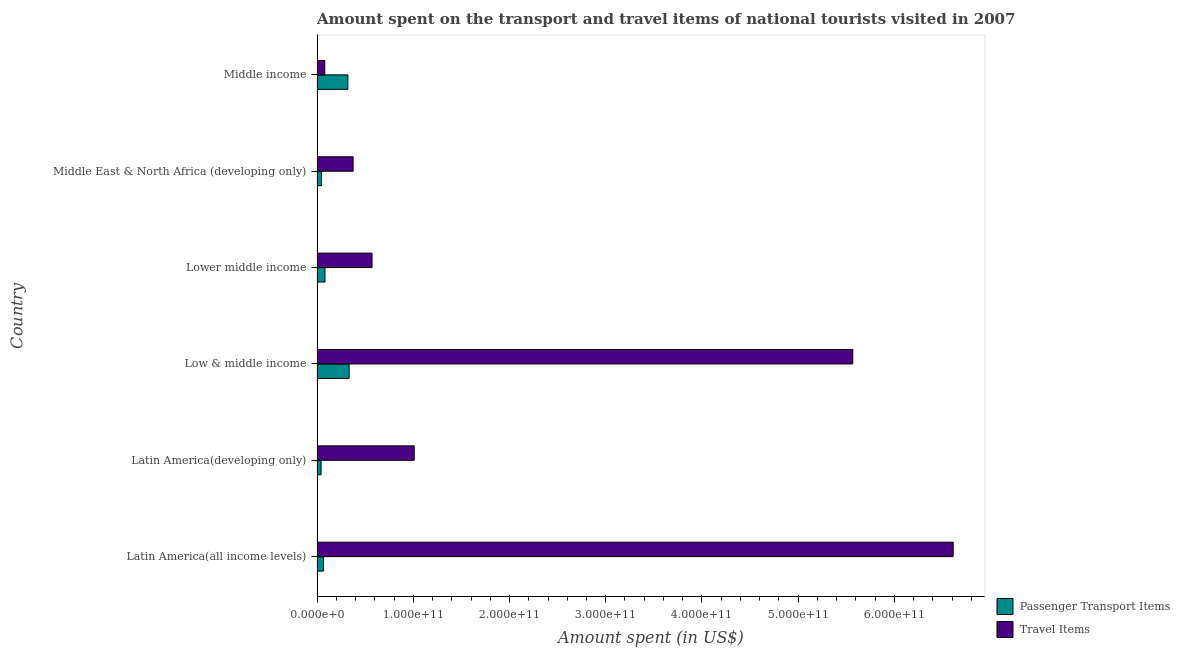How many different coloured bars are there?
Offer a terse response. 2. Are the number of bars on each tick of the Y-axis equal?
Offer a very short reply. Yes. How many bars are there on the 6th tick from the top?
Make the answer very short. 2. What is the label of the 5th group of bars from the top?
Your answer should be compact. Latin America(developing only). In how many cases, is the number of bars for a given country not equal to the number of legend labels?
Keep it short and to the point. 0. What is the amount spent on passenger transport items in Low & middle income?
Make the answer very short. 3.34e+1. Across all countries, what is the maximum amount spent in travel items?
Make the answer very short. 6.61e+11. Across all countries, what is the minimum amount spent in travel items?
Keep it short and to the point. 8.03e+09. In which country was the amount spent in travel items maximum?
Give a very brief answer. Latin America(all income levels). In which country was the amount spent in travel items minimum?
Give a very brief answer. Middle income. What is the total amount spent in travel items in the graph?
Give a very brief answer. 1.42e+12. What is the difference between the amount spent in travel items in Latin America(developing only) and that in Lower middle income?
Offer a terse response. 4.38e+1. What is the difference between the amount spent in travel items in Latin America(developing only) and the amount spent on passenger transport items in Lower middle income?
Make the answer very short. 9.27e+1. What is the average amount spent in travel items per country?
Provide a short and direct response. 2.37e+11. What is the difference between the amount spent in travel items and amount spent on passenger transport items in Latin America(developing only)?
Keep it short and to the point. 9.68e+1. In how many countries, is the amount spent on passenger transport items greater than 400000000000 US$?
Your response must be concise. 0. What is the ratio of the amount spent on passenger transport items in Latin America(developing only) to that in Middle income?
Ensure brevity in your answer.  0.13. Is the difference between the amount spent in travel items in Latin America(all income levels) and Low & middle income greater than the difference between the amount spent on passenger transport items in Latin America(all income levels) and Low & middle income?
Your response must be concise. Yes. What is the difference between the highest and the second highest amount spent in travel items?
Provide a succinct answer. 1.04e+11. What is the difference between the highest and the lowest amount spent on passenger transport items?
Provide a short and direct response. 2.92e+1. In how many countries, is the amount spent on passenger transport items greater than the average amount spent on passenger transport items taken over all countries?
Provide a succinct answer. 2. Is the sum of the amount spent in travel items in Latin America(all income levels) and Middle income greater than the maximum amount spent on passenger transport items across all countries?
Ensure brevity in your answer.  Yes. What does the 1st bar from the top in Lower middle income represents?
Your answer should be compact. Travel Items. What does the 1st bar from the bottom in Lower middle income represents?
Give a very brief answer. Passenger Transport Items. What is the difference between two consecutive major ticks on the X-axis?
Your answer should be compact. 1.00e+11. Does the graph contain any zero values?
Make the answer very short. No. Does the graph contain grids?
Your answer should be very brief. No. How are the legend labels stacked?
Give a very brief answer. Vertical. What is the title of the graph?
Your answer should be compact. Amount spent on the transport and travel items of national tourists visited in 2007. What is the label or title of the X-axis?
Make the answer very short. Amount spent (in US$). What is the Amount spent (in US$) in Passenger Transport Items in Latin America(all income levels)?
Provide a succinct answer. 6.67e+09. What is the Amount spent (in US$) in Travel Items in Latin America(all income levels)?
Your response must be concise. 6.61e+11. What is the Amount spent (in US$) of Passenger Transport Items in Latin America(developing only)?
Provide a short and direct response. 4.17e+09. What is the Amount spent (in US$) in Travel Items in Latin America(developing only)?
Provide a short and direct response. 1.01e+11. What is the Amount spent (in US$) in Passenger Transport Items in Low & middle income?
Make the answer very short. 3.34e+1. What is the Amount spent (in US$) in Travel Items in Low & middle income?
Offer a very short reply. 5.57e+11. What is the Amount spent (in US$) in Passenger Transport Items in Lower middle income?
Your answer should be compact. 8.22e+09. What is the Amount spent (in US$) of Travel Items in Lower middle income?
Provide a succinct answer. 5.71e+1. What is the Amount spent (in US$) of Passenger Transport Items in Middle East & North Africa (developing only)?
Make the answer very short. 4.64e+09. What is the Amount spent (in US$) in Travel Items in Middle East & North Africa (developing only)?
Your answer should be compact. 3.75e+1. What is the Amount spent (in US$) in Passenger Transport Items in Middle income?
Ensure brevity in your answer.  3.20e+1. What is the Amount spent (in US$) of Travel Items in Middle income?
Your answer should be compact. 8.03e+09. Across all countries, what is the maximum Amount spent (in US$) in Passenger Transport Items?
Offer a very short reply. 3.34e+1. Across all countries, what is the maximum Amount spent (in US$) in Travel Items?
Your answer should be very brief. 6.61e+11. Across all countries, what is the minimum Amount spent (in US$) of Passenger Transport Items?
Provide a short and direct response. 4.17e+09. Across all countries, what is the minimum Amount spent (in US$) in Travel Items?
Ensure brevity in your answer.  8.03e+09. What is the total Amount spent (in US$) in Passenger Transport Items in the graph?
Provide a succinct answer. 8.91e+1. What is the total Amount spent (in US$) of Travel Items in the graph?
Give a very brief answer. 1.42e+12. What is the difference between the Amount spent (in US$) of Passenger Transport Items in Latin America(all income levels) and that in Latin America(developing only)?
Your response must be concise. 2.50e+09. What is the difference between the Amount spent (in US$) of Travel Items in Latin America(all income levels) and that in Latin America(developing only)?
Keep it short and to the point. 5.60e+11. What is the difference between the Amount spent (in US$) of Passenger Transport Items in Latin America(all income levels) and that in Low & middle income?
Your response must be concise. -2.67e+1. What is the difference between the Amount spent (in US$) of Travel Items in Latin America(all income levels) and that in Low & middle income?
Your answer should be compact. 1.04e+11. What is the difference between the Amount spent (in US$) in Passenger Transport Items in Latin America(all income levels) and that in Lower middle income?
Your answer should be very brief. -1.55e+09. What is the difference between the Amount spent (in US$) in Travel Items in Latin America(all income levels) and that in Lower middle income?
Provide a succinct answer. 6.04e+11. What is the difference between the Amount spent (in US$) in Passenger Transport Items in Latin America(all income levels) and that in Middle East & North Africa (developing only)?
Your response must be concise. 2.03e+09. What is the difference between the Amount spent (in US$) of Travel Items in Latin America(all income levels) and that in Middle East & North Africa (developing only)?
Your answer should be compact. 6.24e+11. What is the difference between the Amount spent (in US$) in Passenger Transport Items in Latin America(all income levels) and that in Middle income?
Make the answer very short. -2.54e+1. What is the difference between the Amount spent (in US$) of Travel Items in Latin America(all income levels) and that in Middle income?
Ensure brevity in your answer.  6.53e+11. What is the difference between the Amount spent (in US$) in Passenger Transport Items in Latin America(developing only) and that in Low & middle income?
Keep it short and to the point. -2.92e+1. What is the difference between the Amount spent (in US$) in Travel Items in Latin America(developing only) and that in Low & middle income?
Provide a short and direct response. -4.56e+11. What is the difference between the Amount spent (in US$) in Passenger Transport Items in Latin America(developing only) and that in Lower middle income?
Your answer should be very brief. -4.05e+09. What is the difference between the Amount spent (in US$) in Travel Items in Latin America(developing only) and that in Lower middle income?
Offer a terse response. 4.38e+1. What is the difference between the Amount spent (in US$) in Passenger Transport Items in Latin America(developing only) and that in Middle East & North Africa (developing only)?
Give a very brief answer. -4.66e+08. What is the difference between the Amount spent (in US$) of Travel Items in Latin America(developing only) and that in Middle East & North Africa (developing only)?
Ensure brevity in your answer.  6.35e+1. What is the difference between the Amount spent (in US$) of Passenger Transport Items in Latin America(developing only) and that in Middle income?
Your answer should be very brief. -2.79e+1. What is the difference between the Amount spent (in US$) in Travel Items in Latin America(developing only) and that in Middle income?
Your answer should be compact. 9.29e+1. What is the difference between the Amount spent (in US$) in Passenger Transport Items in Low & middle income and that in Lower middle income?
Your response must be concise. 2.51e+1. What is the difference between the Amount spent (in US$) of Travel Items in Low & middle income and that in Lower middle income?
Make the answer very short. 5.00e+11. What is the difference between the Amount spent (in US$) of Passenger Transport Items in Low & middle income and that in Middle East & North Africa (developing only)?
Ensure brevity in your answer.  2.87e+1. What is the difference between the Amount spent (in US$) in Travel Items in Low & middle income and that in Middle East & North Africa (developing only)?
Your answer should be compact. 5.19e+11. What is the difference between the Amount spent (in US$) in Passenger Transport Items in Low & middle income and that in Middle income?
Offer a terse response. 1.33e+09. What is the difference between the Amount spent (in US$) of Travel Items in Low & middle income and that in Middle income?
Provide a short and direct response. 5.49e+11. What is the difference between the Amount spent (in US$) of Passenger Transport Items in Lower middle income and that in Middle East & North Africa (developing only)?
Your response must be concise. 3.58e+09. What is the difference between the Amount spent (in US$) in Travel Items in Lower middle income and that in Middle East & North Africa (developing only)?
Make the answer very short. 1.97e+1. What is the difference between the Amount spent (in US$) in Passenger Transport Items in Lower middle income and that in Middle income?
Provide a short and direct response. -2.38e+1. What is the difference between the Amount spent (in US$) of Travel Items in Lower middle income and that in Middle income?
Your response must be concise. 4.91e+1. What is the difference between the Amount spent (in US$) in Passenger Transport Items in Middle East & North Africa (developing only) and that in Middle income?
Your answer should be compact. -2.74e+1. What is the difference between the Amount spent (in US$) in Travel Items in Middle East & North Africa (developing only) and that in Middle income?
Give a very brief answer. 2.94e+1. What is the difference between the Amount spent (in US$) in Passenger Transport Items in Latin America(all income levels) and the Amount spent (in US$) in Travel Items in Latin America(developing only)?
Your response must be concise. -9.43e+1. What is the difference between the Amount spent (in US$) in Passenger Transport Items in Latin America(all income levels) and the Amount spent (in US$) in Travel Items in Low & middle income?
Provide a succinct answer. -5.50e+11. What is the difference between the Amount spent (in US$) in Passenger Transport Items in Latin America(all income levels) and the Amount spent (in US$) in Travel Items in Lower middle income?
Keep it short and to the point. -5.05e+1. What is the difference between the Amount spent (in US$) of Passenger Transport Items in Latin America(all income levels) and the Amount spent (in US$) of Travel Items in Middle East & North Africa (developing only)?
Provide a succinct answer. -3.08e+1. What is the difference between the Amount spent (in US$) of Passenger Transport Items in Latin America(all income levels) and the Amount spent (in US$) of Travel Items in Middle income?
Keep it short and to the point. -1.36e+09. What is the difference between the Amount spent (in US$) in Passenger Transport Items in Latin America(developing only) and the Amount spent (in US$) in Travel Items in Low & middle income?
Give a very brief answer. -5.53e+11. What is the difference between the Amount spent (in US$) in Passenger Transport Items in Latin America(developing only) and the Amount spent (in US$) in Travel Items in Lower middle income?
Offer a terse response. -5.30e+1. What is the difference between the Amount spent (in US$) in Passenger Transport Items in Latin America(developing only) and the Amount spent (in US$) in Travel Items in Middle East & North Africa (developing only)?
Your response must be concise. -3.33e+1. What is the difference between the Amount spent (in US$) of Passenger Transport Items in Latin America(developing only) and the Amount spent (in US$) of Travel Items in Middle income?
Offer a very short reply. -3.86e+09. What is the difference between the Amount spent (in US$) of Passenger Transport Items in Low & middle income and the Amount spent (in US$) of Travel Items in Lower middle income?
Give a very brief answer. -2.38e+1. What is the difference between the Amount spent (in US$) in Passenger Transport Items in Low & middle income and the Amount spent (in US$) in Travel Items in Middle East & North Africa (developing only)?
Provide a short and direct response. -4.13e+09. What is the difference between the Amount spent (in US$) of Passenger Transport Items in Low & middle income and the Amount spent (in US$) of Travel Items in Middle income?
Provide a short and direct response. 2.53e+1. What is the difference between the Amount spent (in US$) of Passenger Transport Items in Lower middle income and the Amount spent (in US$) of Travel Items in Middle East & North Africa (developing only)?
Provide a succinct answer. -2.93e+1. What is the difference between the Amount spent (in US$) of Passenger Transport Items in Lower middle income and the Amount spent (in US$) of Travel Items in Middle income?
Offer a very short reply. 1.87e+08. What is the difference between the Amount spent (in US$) of Passenger Transport Items in Middle East & North Africa (developing only) and the Amount spent (in US$) of Travel Items in Middle income?
Give a very brief answer. -3.39e+09. What is the average Amount spent (in US$) in Passenger Transport Items per country?
Keep it short and to the point. 1.48e+1. What is the average Amount spent (in US$) of Travel Items per country?
Make the answer very short. 2.37e+11. What is the difference between the Amount spent (in US$) in Passenger Transport Items and Amount spent (in US$) in Travel Items in Latin America(all income levels)?
Offer a very short reply. -6.54e+11. What is the difference between the Amount spent (in US$) in Passenger Transport Items and Amount spent (in US$) in Travel Items in Latin America(developing only)?
Offer a terse response. -9.68e+1. What is the difference between the Amount spent (in US$) of Passenger Transport Items and Amount spent (in US$) of Travel Items in Low & middle income?
Ensure brevity in your answer.  -5.23e+11. What is the difference between the Amount spent (in US$) of Passenger Transport Items and Amount spent (in US$) of Travel Items in Lower middle income?
Your answer should be very brief. -4.89e+1. What is the difference between the Amount spent (in US$) in Passenger Transport Items and Amount spent (in US$) in Travel Items in Middle East & North Africa (developing only)?
Keep it short and to the point. -3.28e+1. What is the difference between the Amount spent (in US$) of Passenger Transport Items and Amount spent (in US$) of Travel Items in Middle income?
Give a very brief answer. 2.40e+1. What is the ratio of the Amount spent (in US$) in Passenger Transport Items in Latin America(all income levels) to that in Latin America(developing only)?
Your answer should be very brief. 1.6. What is the ratio of the Amount spent (in US$) in Travel Items in Latin America(all income levels) to that in Latin America(developing only)?
Your answer should be compact. 6.55. What is the ratio of the Amount spent (in US$) in Travel Items in Latin America(all income levels) to that in Low & middle income?
Offer a very short reply. 1.19. What is the ratio of the Amount spent (in US$) in Passenger Transport Items in Latin America(all income levels) to that in Lower middle income?
Offer a terse response. 0.81. What is the ratio of the Amount spent (in US$) in Travel Items in Latin America(all income levels) to that in Lower middle income?
Keep it short and to the point. 11.57. What is the ratio of the Amount spent (in US$) of Passenger Transport Items in Latin America(all income levels) to that in Middle East & North Africa (developing only)?
Offer a very short reply. 1.44. What is the ratio of the Amount spent (in US$) in Travel Items in Latin America(all income levels) to that in Middle East & North Africa (developing only)?
Provide a short and direct response. 17.64. What is the ratio of the Amount spent (in US$) of Passenger Transport Items in Latin America(all income levels) to that in Middle income?
Provide a succinct answer. 0.21. What is the ratio of the Amount spent (in US$) in Travel Items in Latin America(all income levels) to that in Middle income?
Make the answer very short. 82.29. What is the ratio of the Amount spent (in US$) of Passenger Transport Items in Latin America(developing only) to that in Low & middle income?
Your answer should be compact. 0.13. What is the ratio of the Amount spent (in US$) in Travel Items in Latin America(developing only) to that in Low & middle income?
Your answer should be very brief. 0.18. What is the ratio of the Amount spent (in US$) in Passenger Transport Items in Latin America(developing only) to that in Lower middle income?
Ensure brevity in your answer.  0.51. What is the ratio of the Amount spent (in US$) in Travel Items in Latin America(developing only) to that in Lower middle income?
Your answer should be compact. 1.77. What is the ratio of the Amount spent (in US$) in Passenger Transport Items in Latin America(developing only) to that in Middle East & North Africa (developing only)?
Make the answer very short. 0.9. What is the ratio of the Amount spent (in US$) in Travel Items in Latin America(developing only) to that in Middle East & North Africa (developing only)?
Your answer should be very brief. 2.69. What is the ratio of the Amount spent (in US$) in Passenger Transport Items in Latin America(developing only) to that in Middle income?
Your answer should be compact. 0.13. What is the ratio of the Amount spent (in US$) of Travel Items in Latin America(developing only) to that in Middle income?
Provide a succinct answer. 12.57. What is the ratio of the Amount spent (in US$) of Passenger Transport Items in Low & middle income to that in Lower middle income?
Offer a terse response. 4.06. What is the ratio of the Amount spent (in US$) of Travel Items in Low & middle income to that in Lower middle income?
Your answer should be very brief. 9.74. What is the ratio of the Amount spent (in US$) of Passenger Transport Items in Low & middle income to that in Middle East & North Africa (developing only)?
Keep it short and to the point. 7.19. What is the ratio of the Amount spent (in US$) in Travel Items in Low & middle income to that in Middle East & North Africa (developing only)?
Give a very brief answer. 14.85. What is the ratio of the Amount spent (in US$) of Passenger Transport Items in Low & middle income to that in Middle income?
Provide a short and direct response. 1.04. What is the ratio of the Amount spent (in US$) of Travel Items in Low & middle income to that in Middle income?
Ensure brevity in your answer.  69.3. What is the ratio of the Amount spent (in US$) of Passenger Transport Items in Lower middle income to that in Middle East & North Africa (developing only)?
Provide a succinct answer. 1.77. What is the ratio of the Amount spent (in US$) of Travel Items in Lower middle income to that in Middle East & North Africa (developing only)?
Keep it short and to the point. 1.52. What is the ratio of the Amount spent (in US$) in Passenger Transport Items in Lower middle income to that in Middle income?
Your response must be concise. 0.26. What is the ratio of the Amount spent (in US$) in Travel Items in Lower middle income to that in Middle income?
Provide a succinct answer. 7.11. What is the ratio of the Amount spent (in US$) of Passenger Transport Items in Middle East & North Africa (developing only) to that in Middle income?
Provide a short and direct response. 0.14. What is the ratio of the Amount spent (in US$) in Travel Items in Middle East & North Africa (developing only) to that in Middle income?
Make the answer very short. 4.67. What is the difference between the highest and the second highest Amount spent (in US$) of Passenger Transport Items?
Offer a terse response. 1.33e+09. What is the difference between the highest and the second highest Amount spent (in US$) in Travel Items?
Provide a succinct answer. 1.04e+11. What is the difference between the highest and the lowest Amount spent (in US$) in Passenger Transport Items?
Make the answer very short. 2.92e+1. What is the difference between the highest and the lowest Amount spent (in US$) in Travel Items?
Your answer should be compact. 6.53e+11. 